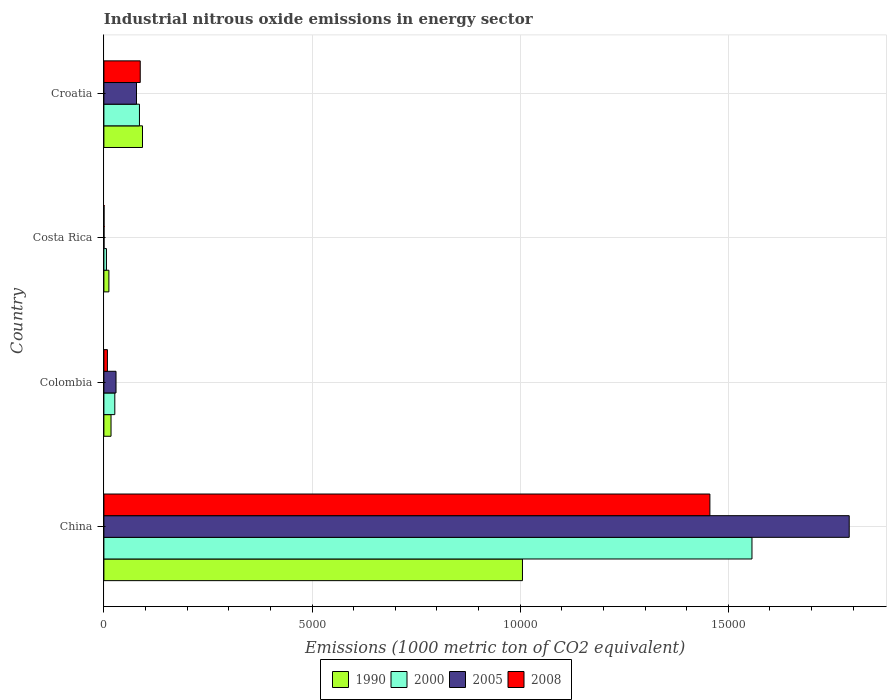How many bars are there on the 4th tick from the top?
Offer a very short reply. 4. How many bars are there on the 3rd tick from the bottom?
Keep it short and to the point. 4. In how many cases, is the number of bars for a given country not equal to the number of legend labels?
Your answer should be very brief. 0. What is the amount of industrial nitrous oxide emitted in 2000 in China?
Keep it short and to the point. 1.56e+04. Across all countries, what is the maximum amount of industrial nitrous oxide emitted in 1990?
Offer a terse response. 1.01e+04. Across all countries, what is the minimum amount of industrial nitrous oxide emitted in 1990?
Ensure brevity in your answer.  120. What is the total amount of industrial nitrous oxide emitted in 2000 in the graph?
Provide a short and direct response. 1.67e+04. What is the difference between the amount of industrial nitrous oxide emitted in 1990 in China and that in Costa Rica?
Provide a succinct answer. 9936.1. What is the difference between the amount of industrial nitrous oxide emitted in 2008 in Colombia and the amount of industrial nitrous oxide emitted in 2000 in Costa Rica?
Ensure brevity in your answer.  23.3. What is the average amount of industrial nitrous oxide emitted in 2008 per country?
Your response must be concise. 3879.93. What is the difference between the amount of industrial nitrous oxide emitted in 2000 and amount of industrial nitrous oxide emitted in 1990 in Costa Rica?
Keep it short and to the point. -58.6. In how many countries, is the amount of industrial nitrous oxide emitted in 1990 greater than 4000 1000 metric ton?
Make the answer very short. 1. What is the ratio of the amount of industrial nitrous oxide emitted in 2005 in China to that in Croatia?
Offer a terse response. 22.86. What is the difference between the highest and the second highest amount of industrial nitrous oxide emitted in 2000?
Offer a very short reply. 1.47e+04. What is the difference between the highest and the lowest amount of industrial nitrous oxide emitted in 2000?
Provide a succinct answer. 1.55e+04. Is it the case that in every country, the sum of the amount of industrial nitrous oxide emitted in 2008 and amount of industrial nitrous oxide emitted in 2005 is greater than the amount of industrial nitrous oxide emitted in 2000?
Offer a very short reply. No. How many bars are there?
Offer a very short reply. 16. How many countries are there in the graph?
Give a very brief answer. 4. Does the graph contain any zero values?
Ensure brevity in your answer.  No. Does the graph contain grids?
Your answer should be compact. Yes. How are the legend labels stacked?
Give a very brief answer. Horizontal. What is the title of the graph?
Make the answer very short. Industrial nitrous oxide emissions in energy sector. Does "1983" appear as one of the legend labels in the graph?
Keep it short and to the point. No. What is the label or title of the X-axis?
Your answer should be very brief. Emissions (1000 metric ton of CO2 equivalent). What is the Emissions (1000 metric ton of CO2 equivalent) of 1990 in China?
Ensure brevity in your answer.  1.01e+04. What is the Emissions (1000 metric ton of CO2 equivalent) of 2000 in China?
Ensure brevity in your answer.  1.56e+04. What is the Emissions (1000 metric ton of CO2 equivalent) of 2005 in China?
Your answer should be compact. 1.79e+04. What is the Emissions (1000 metric ton of CO2 equivalent) in 2008 in China?
Your answer should be very brief. 1.46e+04. What is the Emissions (1000 metric ton of CO2 equivalent) in 1990 in Colombia?
Provide a short and direct response. 171.6. What is the Emissions (1000 metric ton of CO2 equivalent) in 2000 in Colombia?
Provide a succinct answer. 262.3. What is the Emissions (1000 metric ton of CO2 equivalent) in 2005 in Colombia?
Give a very brief answer. 291.3. What is the Emissions (1000 metric ton of CO2 equivalent) of 2008 in Colombia?
Offer a very short reply. 84.7. What is the Emissions (1000 metric ton of CO2 equivalent) of 1990 in Costa Rica?
Your answer should be compact. 120. What is the Emissions (1000 metric ton of CO2 equivalent) of 2000 in Costa Rica?
Offer a terse response. 61.4. What is the Emissions (1000 metric ton of CO2 equivalent) of 1990 in Croatia?
Keep it short and to the point. 927.7. What is the Emissions (1000 metric ton of CO2 equivalent) of 2000 in Croatia?
Keep it short and to the point. 854.3. What is the Emissions (1000 metric ton of CO2 equivalent) in 2005 in Croatia?
Your response must be concise. 783.2. What is the Emissions (1000 metric ton of CO2 equivalent) in 2008 in Croatia?
Offer a terse response. 873. Across all countries, what is the maximum Emissions (1000 metric ton of CO2 equivalent) of 1990?
Give a very brief answer. 1.01e+04. Across all countries, what is the maximum Emissions (1000 metric ton of CO2 equivalent) of 2000?
Keep it short and to the point. 1.56e+04. Across all countries, what is the maximum Emissions (1000 metric ton of CO2 equivalent) of 2005?
Keep it short and to the point. 1.79e+04. Across all countries, what is the maximum Emissions (1000 metric ton of CO2 equivalent) of 2008?
Offer a terse response. 1.46e+04. Across all countries, what is the minimum Emissions (1000 metric ton of CO2 equivalent) of 1990?
Provide a succinct answer. 120. Across all countries, what is the minimum Emissions (1000 metric ton of CO2 equivalent) in 2000?
Provide a succinct answer. 61.4. What is the total Emissions (1000 metric ton of CO2 equivalent) of 1990 in the graph?
Provide a succinct answer. 1.13e+04. What is the total Emissions (1000 metric ton of CO2 equivalent) in 2000 in the graph?
Provide a short and direct response. 1.67e+04. What is the total Emissions (1000 metric ton of CO2 equivalent) of 2005 in the graph?
Offer a very short reply. 1.90e+04. What is the total Emissions (1000 metric ton of CO2 equivalent) in 2008 in the graph?
Offer a very short reply. 1.55e+04. What is the difference between the Emissions (1000 metric ton of CO2 equivalent) of 1990 in China and that in Colombia?
Provide a succinct answer. 9884.5. What is the difference between the Emissions (1000 metric ton of CO2 equivalent) of 2000 in China and that in Colombia?
Your answer should be very brief. 1.53e+04. What is the difference between the Emissions (1000 metric ton of CO2 equivalent) in 2005 in China and that in Colombia?
Make the answer very short. 1.76e+04. What is the difference between the Emissions (1000 metric ton of CO2 equivalent) in 2008 in China and that in Colombia?
Your answer should be compact. 1.45e+04. What is the difference between the Emissions (1000 metric ton of CO2 equivalent) of 1990 in China and that in Costa Rica?
Keep it short and to the point. 9936.1. What is the difference between the Emissions (1000 metric ton of CO2 equivalent) of 2000 in China and that in Costa Rica?
Your answer should be very brief. 1.55e+04. What is the difference between the Emissions (1000 metric ton of CO2 equivalent) in 2005 in China and that in Costa Rica?
Give a very brief answer. 1.79e+04. What is the difference between the Emissions (1000 metric ton of CO2 equivalent) in 2008 in China and that in Costa Rica?
Provide a short and direct response. 1.46e+04. What is the difference between the Emissions (1000 metric ton of CO2 equivalent) of 1990 in China and that in Croatia?
Offer a terse response. 9128.4. What is the difference between the Emissions (1000 metric ton of CO2 equivalent) in 2000 in China and that in Croatia?
Make the answer very short. 1.47e+04. What is the difference between the Emissions (1000 metric ton of CO2 equivalent) of 2005 in China and that in Croatia?
Your answer should be compact. 1.71e+04. What is the difference between the Emissions (1000 metric ton of CO2 equivalent) in 2008 in China and that in Croatia?
Offer a terse response. 1.37e+04. What is the difference between the Emissions (1000 metric ton of CO2 equivalent) in 1990 in Colombia and that in Costa Rica?
Your answer should be very brief. 51.6. What is the difference between the Emissions (1000 metric ton of CO2 equivalent) in 2000 in Colombia and that in Costa Rica?
Offer a very short reply. 200.9. What is the difference between the Emissions (1000 metric ton of CO2 equivalent) in 2005 in Colombia and that in Costa Rica?
Your answer should be very brief. 288.2. What is the difference between the Emissions (1000 metric ton of CO2 equivalent) in 2008 in Colombia and that in Costa Rica?
Give a very brief answer. 81.6. What is the difference between the Emissions (1000 metric ton of CO2 equivalent) in 1990 in Colombia and that in Croatia?
Give a very brief answer. -756.1. What is the difference between the Emissions (1000 metric ton of CO2 equivalent) of 2000 in Colombia and that in Croatia?
Your answer should be very brief. -592. What is the difference between the Emissions (1000 metric ton of CO2 equivalent) in 2005 in Colombia and that in Croatia?
Ensure brevity in your answer.  -491.9. What is the difference between the Emissions (1000 metric ton of CO2 equivalent) in 2008 in Colombia and that in Croatia?
Provide a succinct answer. -788.3. What is the difference between the Emissions (1000 metric ton of CO2 equivalent) of 1990 in Costa Rica and that in Croatia?
Provide a short and direct response. -807.7. What is the difference between the Emissions (1000 metric ton of CO2 equivalent) of 2000 in Costa Rica and that in Croatia?
Offer a very short reply. -792.9. What is the difference between the Emissions (1000 metric ton of CO2 equivalent) of 2005 in Costa Rica and that in Croatia?
Provide a short and direct response. -780.1. What is the difference between the Emissions (1000 metric ton of CO2 equivalent) of 2008 in Costa Rica and that in Croatia?
Offer a terse response. -869.9. What is the difference between the Emissions (1000 metric ton of CO2 equivalent) in 1990 in China and the Emissions (1000 metric ton of CO2 equivalent) in 2000 in Colombia?
Your answer should be very brief. 9793.8. What is the difference between the Emissions (1000 metric ton of CO2 equivalent) in 1990 in China and the Emissions (1000 metric ton of CO2 equivalent) in 2005 in Colombia?
Your answer should be compact. 9764.8. What is the difference between the Emissions (1000 metric ton of CO2 equivalent) of 1990 in China and the Emissions (1000 metric ton of CO2 equivalent) of 2008 in Colombia?
Ensure brevity in your answer.  9971.4. What is the difference between the Emissions (1000 metric ton of CO2 equivalent) of 2000 in China and the Emissions (1000 metric ton of CO2 equivalent) of 2005 in Colombia?
Give a very brief answer. 1.53e+04. What is the difference between the Emissions (1000 metric ton of CO2 equivalent) of 2000 in China and the Emissions (1000 metric ton of CO2 equivalent) of 2008 in Colombia?
Make the answer very short. 1.55e+04. What is the difference between the Emissions (1000 metric ton of CO2 equivalent) of 2005 in China and the Emissions (1000 metric ton of CO2 equivalent) of 2008 in Colombia?
Your answer should be very brief. 1.78e+04. What is the difference between the Emissions (1000 metric ton of CO2 equivalent) of 1990 in China and the Emissions (1000 metric ton of CO2 equivalent) of 2000 in Costa Rica?
Offer a terse response. 9994.7. What is the difference between the Emissions (1000 metric ton of CO2 equivalent) in 1990 in China and the Emissions (1000 metric ton of CO2 equivalent) in 2005 in Costa Rica?
Provide a succinct answer. 1.01e+04. What is the difference between the Emissions (1000 metric ton of CO2 equivalent) in 1990 in China and the Emissions (1000 metric ton of CO2 equivalent) in 2008 in Costa Rica?
Your answer should be compact. 1.01e+04. What is the difference between the Emissions (1000 metric ton of CO2 equivalent) in 2000 in China and the Emissions (1000 metric ton of CO2 equivalent) in 2005 in Costa Rica?
Your answer should be very brief. 1.56e+04. What is the difference between the Emissions (1000 metric ton of CO2 equivalent) in 2000 in China and the Emissions (1000 metric ton of CO2 equivalent) in 2008 in Costa Rica?
Offer a terse response. 1.56e+04. What is the difference between the Emissions (1000 metric ton of CO2 equivalent) of 2005 in China and the Emissions (1000 metric ton of CO2 equivalent) of 2008 in Costa Rica?
Give a very brief answer. 1.79e+04. What is the difference between the Emissions (1000 metric ton of CO2 equivalent) in 1990 in China and the Emissions (1000 metric ton of CO2 equivalent) in 2000 in Croatia?
Your answer should be compact. 9201.8. What is the difference between the Emissions (1000 metric ton of CO2 equivalent) of 1990 in China and the Emissions (1000 metric ton of CO2 equivalent) of 2005 in Croatia?
Offer a very short reply. 9272.9. What is the difference between the Emissions (1000 metric ton of CO2 equivalent) in 1990 in China and the Emissions (1000 metric ton of CO2 equivalent) in 2008 in Croatia?
Offer a very short reply. 9183.1. What is the difference between the Emissions (1000 metric ton of CO2 equivalent) in 2000 in China and the Emissions (1000 metric ton of CO2 equivalent) in 2005 in Croatia?
Keep it short and to the point. 1.48e+04. What is the difference between the Emissions (1000 metric ton of CO2 equivalent) of 2000 in China and the Emissions (1000 metric ton of CO2 equivalent) of 2008 in Croatia?
Your response must be concise. 1.47e+04. What is the difference between the Emissions (1000 metric ton of CO2 equivalent) of 2005 in China and the Emissions (1000 metric ton of CO2 equivalent) of 2008 in Croatia?
Your response must be concise. 1.70e+04. What is the difference between the Emissions (1000 metric ton of CO2 equivalent) of 1990 in Colombia and the Emissions (1000 metric ton of CO2 equivalent) of 2000 in Costa Rica?
Offer a very short reply. 110.2. What is the difference between the Emissions (1000 metric ton of CO2 equivalent) in 1990 in Colombia and the Emissions (1000 metric ton of CO2 equivalent) in 2005 in Costa Rica?
Your answer should be compact. 168.5. What is the difference between the Emissions (1000 metric ton of CO2 equivalent) in 1990 in Colombia and the Emissions (1000 metric ton of CO2 equivalent) in 2008 in Costa Rica?
Offer a very short reply. 168.5. What is the difference between the Emissions (1000 metric ton of CO2 equivalent) of 2000 in Colombia and the Emissions (1000 metric ton of CO2 equivalent) of 2005 in Costa Rica?
Your answer should be compact. 259.2. What is the difference between the Emissions (1000 metric ton of CO2 equivalent) in 2000 in Colombia and the Emissions (1000 metric ton of CO2 equivalent) in 2008 in Costa Rica?
Ensure brevity in your answer.  259.2. What is the difference between the Emissions (1000 metric ton of CO2 equivalent) of 2005 in Colombia and the Emissions (1000 metric ton of CO2 equivalent) of 2008 in Costa Rica?
Offer a very short reply. 288.2. What is the difference between the Emissions (1000 metric ton of CO2 equivalent) of 1990 in Colombia and the Emissions (1000 metric ton of CO2 equivalent) of 2000 in Croatia?
Provide a short and direct response. -682.7. What is the difference between the Emissions (1000 metric ton of CO2 equivalent) of 1990 in Colombia and the Emissions (1000 metric ton of CO2 equivalent) of 2005 in Croatia?
Make the answer very short. -611.6. What is the difference between the Emissions (1000 metric ton of CO2 equivalent) in 1990 in Colombia and the Emissions (1000 metric ton of CO2 equivalent) in 2008 in Croatia?
Your answer should be compact. -701.4. What is the difference between the Emissions (1000 metric ton of CO2 equivalent) of 2000 in Colombia and the Emissions (1000 metric ton of CO2 equivalent) of 2005 in Croatia?
Provide a succinct answer. -520.9. What is the difference between the Emissions (1000 metric ton of CO2 equivalent) in 2000 in Colombia and the Emissions (1000 metric ton of CO2 equivalent) in 2008 in Croatia?
Your answer should be very brief. -610.7. What is the difference between the Emissions (1000 metric ton of CO2 equivalent) of 2005 in Colombia and the Emissions (1000 metric ton of CO2 equivalent) of 2008 in Croatia?
Provide a succinct answer. -581.7. What is the difference between the Emissions (1000 metric ton of CO2 equivalent) of 1990 in Costa Rica and the Emissions (1000 metric ton of CO2 equivalent) of 2000 in Croatia?
Your answer should be compact. -734.3. What is the difference between the Emissions (1000 metric ton of CO2 equivalent) of 1990 in Costa Rica and the Emissions (1000 metric ton of CO2 equivalent) of 2005 in Croatia?
Your answer should be compact. -663.2. What is the difference between the Emissions (1000 metric ton of CO2 equivalent) in 1990 in Costa Rica and the Emissions (1000 metric ton of CO2 equivalent) in 2008 in Croatia?
Offer a terse response. -753. What is the difference between the Emissions (1000 metric ton of CO2 equivalent) of 2000 in Costa Rica and the Emissions (1000 metric ton of CO2 equivalent) of 2005 in Croatia?
Provide a short and direct response. -721.8. What is the difference between the Emissions (1000 metric ton of CO2 equivalent) of 2000 in Costa Rica and the Emissions (1000 metric ton of CO2 equivalent) of 2008 in Croatia?
Your response must be concise. -811.6. What is the difference between the Emissions (1000 metric ton of CO2 equivalent) in 2005 in Costa Rica and the Emissions (1000 metric ton of CO2 equivalent) in 2008 in Croatia?
Your response must be concise. -869.9. What is the average Emissions (1000 metric ton of CO2 equivalent) of 1990 per country?
Offer a terse response. 2818.85. What is the average Emissions (1000 metric ton of CO2 equivalent) in 2000 per country?
Your answer should be compact. 4186.93. What is the average Emissions (1000 metric ton of CO2 equivalent) in 2005 per country?
Your answer should be very brief. 4746. What is the average Emissions (1000 metric ton of CO2 equivalent) of 2008 per country?
Ensure brevity in your answer.  3879.93. What is the difference between the Emissions (1000 metric ton of CO2 equivalent) in 1990 and Emissions (1000 metric ton of CO2 equivalent) in 2000 in China?
Your answer should be compact. -5513.6. What is the difference between the Emissions (1000 metric ton of CO2 equivalent) in 1990 and Emissions (1000 metric ton of CO2 equivalent) in 2005 in China?
Offer a terse response. -7850.3. What is the difference between the Emissions (1000 metric ton of CO2 equivalent) of 1990 and Emissions (1000 metric ton of CO2 equivalent) of 2008 in China?
Ensure brevity in your answer.  -4502.8. What is the difference between the Emissions (1000 metric ton of CO2 equivalent) of 2000 and Emissions (1000 metric ton of CO2 equivalent) of 2005 in China?
Give a very brief answer. -2336.7. What is the difference between the Emissions (1000 metric ton of CO2 equivalent) of 2000 and Emissions (1000 metric ton of CO2 equivalent) of 2008 in China?
Offer a very short reply. 1010.8. What is the difference between the Emissions (1000 metric ton of CO2 equivalent) in 2005 and Emissions (1000 metric ton of CO2 equivalent) in 2008 in China?
Provide a short and direct response. 3347.5. What is the difference between the Emissions (1000 metric ton of CO2 equivalent) of 1990 and Emissions (1000 metric ton of CO2 equivalent) of 2000 in Colombia?
Keep it short and to the point. -90.7. What is the difference between the Emissions (1000 metric ton of CO2 equivalent) in 1990 and Emissions (1000 metric ton of CO2 equivalent) in 2005 in Colombia?
Offer a very short reply. -119.7. What is the difference between the Emissions (1000 metric ton of CO2 equivalent) in 1990 and Emissions (1000 metric ton of CO2 equivalent) in 2008 in Colombia?
Provide a short and direct response. 86.9. What is the difference between the Emissions (1000 metric ton of CO2 equivalent) in 2000 and Emissions (1000 metric ton of CO2 equivalent) in 2008 in Colombia?
Your response must be concise. 177.6. What is the difference between the Emissions (1000 metric ton of CO2 equivalent) in 2005 and Emissions (1000 metric ton of CO2 equivalent) in 2008 in Colombia?
Give a very brief answer. 206.6. What is the difference between the Emissions (1000 metric ton of CO2 equivalent) in 1990 and Emissions (1000 metric ton of CO2 equivalent) in 2000 in Costa Rica?
Offer a terse response. 58.6. What is the difference between the Emissions (1000 metric ton of CO2 equivalent) in 1990 and Emissions (1000 metric ton of CO2 equivalent) in 2005 in Costa Rica?
Offer a terse response. 116.9. What is the difference between the Emissions (1000 metric ton of CO2 equivalent) in 1990 and Emissions (1000 metric ton of CO2 equivalent) in 2008 in Costa Rica?
Your answer should be compact. 116.9. What is the difference between the Emissions (1000 metric ton of CO2 equivalent) in 2000 and Emissions (1000 metric ton of CO2 equivalent) in 2005 in Costa Rica?
Ensure brevity in your answer.  58.3. What is the difference between the Emissions (1000 metric ton of CO2 equivalent) in 2000 and Emissions (1000 metric ton of CO2 equivalent) in 2008 in Costa Rica?
Your answer should be very brief. 58.3. What is the difference between the Emissions (1000 metric ton of CO2 equivalent) in 2005 and Emissions (1000 metric ton of CO2 equivalent) in 2008 in Costa Rica?
Give a very brief answer. 0. What is the difference between the Emissions (1000 metric ton of CO2 equivalent) in 1990 and Emissions (1000 metric ton of CO2 equivalent) in 2000 in Croatia?
Your response must be concise. 73.4. What is the difference between the Emissions (1000 metric ton of CO2 equivalent) in 1990 and Emissions (1000 metric ton of CO2 equivalent) in 2005 in Croatia?
Provide a short and direct response. 144.5. What is the difference between the Emissions (1000 metric ton of CO2 equivalent) in 1990 and Emissions (1000 metric ton of CO2 equivalent) in 2008 in Croatia?
Make the answer very short. 54.7. What is the difference between the Emissions (1000 metric ton of CO2 equivalent) of 2000 and Emissions (1000 metric ton of CO2 equivalent) of 2005 in Croatia?
Give a very brief answer. 71.1. What is the difference between the Emissions (1000 metric ton of CO2 equivalent) of 2000 and Emissions (1000 metric ton of CO2 equivalent) of 2008 in Croatia?
Your answer should be very brief. -18.7. What is the difference between the Emissions (1000 metric ton of CO2 equivalent) of 2005 and Emissions (1000 metric ton of CO2 equivalent) of 2008 in Croatia?
Your answer should be very brief. -89.8. What is the ratio of the Emissions (1000 metric ton of CO2 equivalent) of 1990 in China to that in Colombia?
Give a very brief answer. 58.6. What is the ratio of the Emissions (1000 metric ton of CO2 equivalent) of 2000 in China to that in Colombia?
Give a very brief answer. 59.36. What is the ratio of the Emissions (1000 metric ton of CO2 equivalent) in 2005 in China to that in Colombia?
Offer a terse response. 61.47. What is the ratio of the Emissions (1000 metric ton of CO2 equivalent) in 2008 in China to that in Colombia?
Provide a short and direct response. 171.89. What is the ratio of the Emissions (1000 metric ton of CO2 equivalent) in 1990 in China to that in Costa Rica?
Give a very brief answer. 83.8. What is the ratio of the Emissions (1000 metric ton of CO2 equivalent) in 2000 in China to that in Costa Rica?
Your response must be concise. 253.58. What is the ratio of the Emissions (1000 metric ton of CO2 equivalent) of 2005 in China to that in Costa Rica?
Your answer should be very brief. 5776.26. What is the ratio of the Emissions (1000 metric ton of CO2 equivalent) in 2008 in China to that in Costa Rica?
Your answer should be very brief. 4696.42. What is the ratio of the Emissions (1000 metric ton of CO2 equivalent) in 1990 in China to that in Croatia?
Give a very brief answer. 10.84. What is the ratio of the Emissions (1000 metric ton of CO2 equivalent) of 2000 in China to that in Croatia?
Your answer should be compact. 18.23. What is the ratio of the Emissions (1000 metric ton of CO2 equivalent) of 2005 in China to that in Croatia?
Offer a very short reply. 22.86. What is the ratio of the Emissions (1000 metric ton of CO2 equivalent) of 2008 in China to that in Croatia?
Ensure brevity in your answer.  16.68. What is the ratio of the Emissions (1000 metric ton of CO2 equivalent) of 1990 in Colombia to that in Costa Rica?
Offer a terse response. 1.43. What is the ratio of the Emissions (1000 metric ton of CO2 equivalent) of 2000 in Colombia to that in Costa Rica?
Keep it short and to the point. 4.27. What is the ratio of the Emissions (1000 metric ton of CO2 equivalent) in 2005 in Colombia to that in Costa Rica?
Provide a short and direct response. 93.97. What is the ratio of the Emissions (1000 metric ton of CO2 equivalent) of 2008 in Colombia to that in Costa Rica?
Keep it short and to the point. 27.32. What is the ratio of the Emissions (1000 metric ton of CO2 equivalent) in 1990 in Colombia to that in Croatia?
Give a very brief answer. 0.18. What is the ratio of the Emissions (1000 metric ton of CO2 equivalent) of 2000 in Colombia to that in Croatia?
Your answer should be very brief. 0.31. What is the ratio of the Emissions (1000 metric ton of CO2 equivalent) in 2005 in Colombia to that in Croatia?
Keep it short and to the point. 0.37. What is the ratio of the Emissions (1000 metric ton of CO2 equivalent) of 2008 in Colombia to that in Croatia?
Offer a very short reply. 0.1. What is the ratio of the Emissions (1000 metric ton of CO2 equivalent) in 1990 in Costa Rica to that in Croatia?
Your response must be concise. 0.13. What is the ratio of the Emissions (1000 metric ton of CO2 equivalent) of 2000 in Costa Rica to that in Croatia?
Provide a succinct answer. 0.07. What is the ratio of the Emissions (1000 metric ton of CO2 equivalent) of 2005 in Costa Rica to that in Croatia?
Offer a terse response. 0. What is the ratio of the Emissions (1000 metric ton of CO2 equivalent) of 2008 in Costa Rica to that in Croatia?
Provide a succinct answer. 0. What is the difference between the highest and the second highest Emissions (1000 metric ton of CO2 equivalent) of 1990?
Give a very brief answer. 9128.4. What is the difference between the highest and the second highest Emissions (1000 metric ton of CO2 equivalent) in 2000?
Make the answer very short. 1.47e+04. What is the difference between the highest and the second highest Emissions (1000 metric ton of CO2 equivalent) in 2005?
Provide a short and direct response. 1.71e+04. What is the difference between the highest and the second highest Emissions (1000 metric ton of CO2 equivalent) in 2008?
Your answer should be compact. 1.37e+04. What is the difference between the highest and the lowest Emissions (1000 metric ton of CO2 equivalent) of 1990?
Make the answer very short. 9936.1. What is the difference between the highest and the lowest Emissions (1000 metric ton of CO2 equivalent) of 2000?
Your answer should be very brief. 1.55e+04. What is the difference between the highest and the lowest Emissions (1000 metric ton of CO2 equivalent) in 2005?
Your response must be concise. 1.79e+04. What is the difference between the highest and the lowest Emissions (1000 metric ton of CO2 equivalent) in 2008?
Provide a succinct answer. 1.46e+04. 